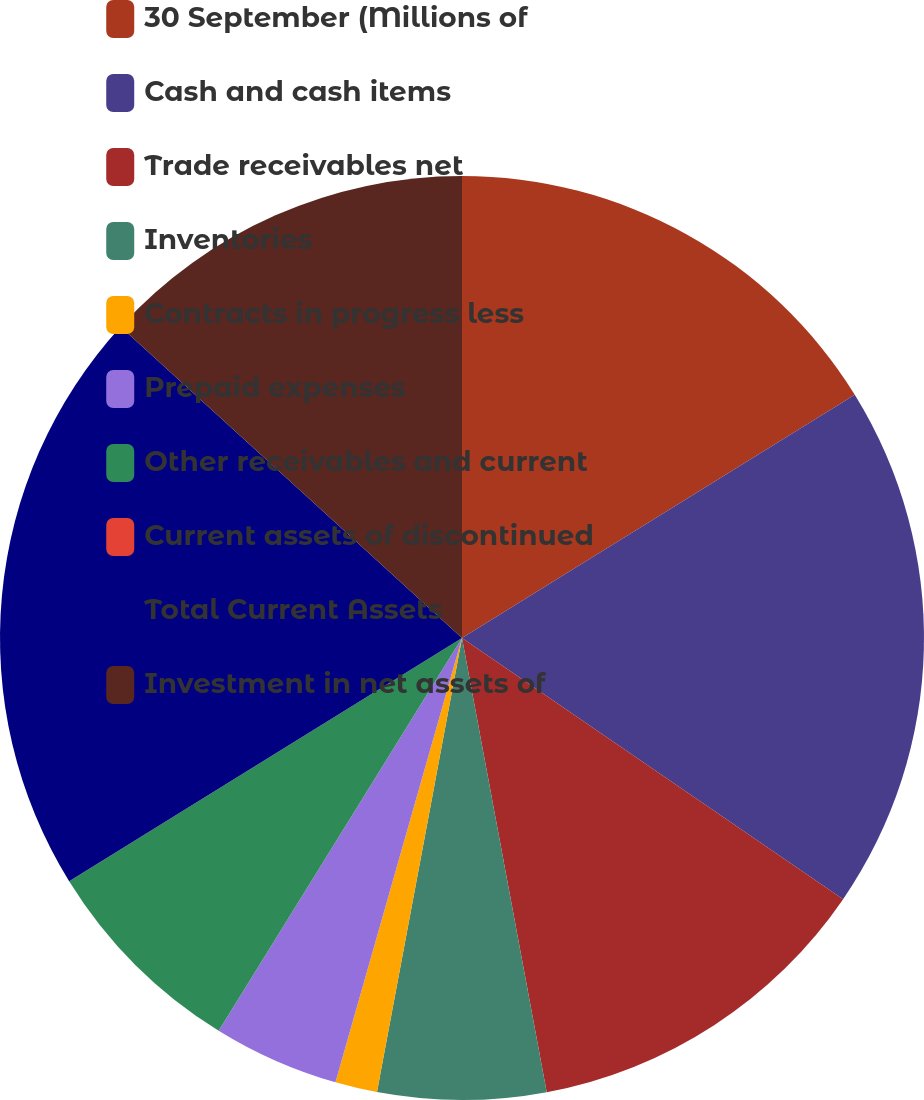<chart> <loc_0><loc_0><loc_500><loc_500><pie_chart><fcel>30 September (Millions of<fcel>Cash and cash items<fcel>Trade receivables net<fcel>Inventories<fcel>Contracts in progress less<fcel>Prepaid expenses<fcel>Other receivables and current<fcel>Current assets of discontinued<fcel>Total Current Assets<fcel>Investment in net assets of<nl><fcel>16.17%<fcel>18.38%<fcel>12.5%<fcel>5.88%<fcel>1.47%<fcel>4.41%<fcel>7.35%<fcel>0.0%<fcel>20.58%<fcel>13.23%<nl></chart> 